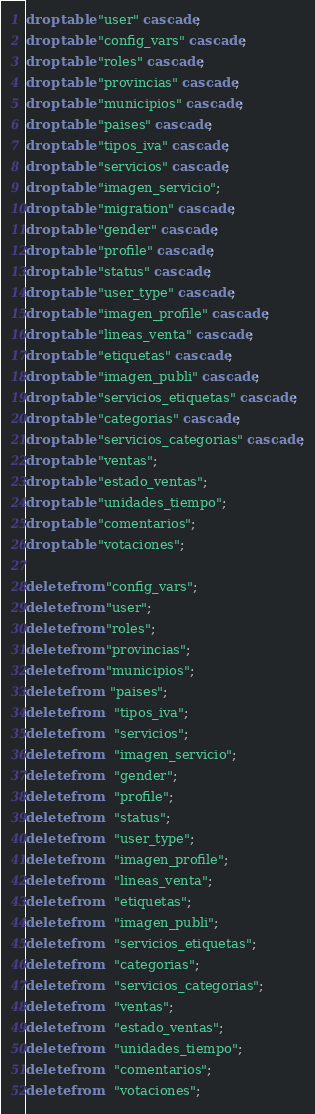<code> <loc_0><loc_0><loc_500><loc_500><_SQL_>drop table "user" cascade;
drop table "config_vars" cascade;
drop table "roles" cascade;
drop table "provincias" cascade;
drop table "municipios" cascade;
drop table "paises" cascade;
drop table "tipos_iva" cascade;
drop table "servicios" cascade;
drop table "imagen_servicio";
drop table "migration" cascade;
drop table "gender" cascade;
drop table "profile" cascade;
drop table "status" cascade;
drop table "user_type" cascade;
drop table "imagen_profile" cascade;
drop table "lineas_venta" cascade;
drop table "etiquetas" cascade;
drop table "imagen_publi" cascade;
drop table "servicios_etiquetas" cascade;
drop table "categorias" cascade;
drop table "servicios_categorias" cascade;
drop table "ventas";
drop table "estado_ventas";
drop table "unidades_tiempo";
drop table "comentarios";
drop table "votaciones";

delete from "config_vars";
delete from "user";
delete from "roles";
delete from "provincias";
delete from "municipios";
delete from  "paises";
delete from   "tipos_iva";
delete from   "servicios";
delete from   "imagen_servicio";
delete from   "gender";
delete from   "profile";
delete from   "status";
delete from   "user_type";
delete from   "imagen_profile";
delete from   "lineas_venta";
delete from   "etiquetas";
delete from   "imagen_publi";
delete from   "servicios_etiquetas";
delete from   "categorias";
delete from   "servicios_categorias";
delete from   "ventas";
delete from   "estado_ventas";
delete from   "unidades_tiempo";
delete from   "comentarios";
delete from   "votaciones";
</code> 